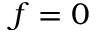<formula> <loc_0><loc_0><loc_500><loc_500>f = 0</formula> 